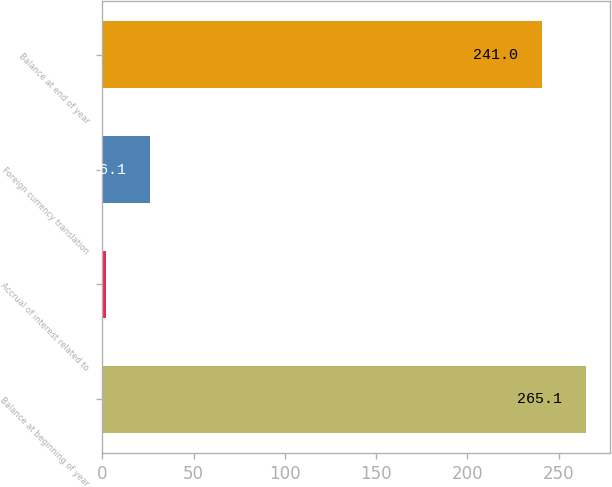Convert chart to OTSL. <chart><loc_0><loc_0><loc_500><loc_500><bar_chart><fcel>Balance at beginning of year<fcel>Accrual of interest related to<fcel>Foreign currency translation<fcel>Balance at end of year<nl><fcel>265.1<fcel>2<fcel>26.1<fcel>241<nl></chart> 